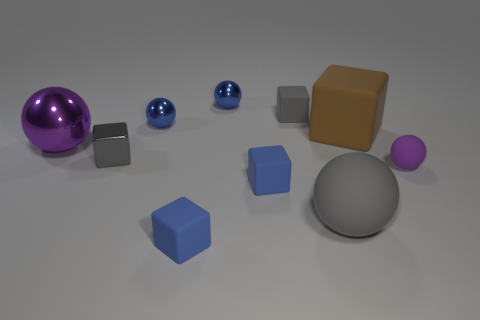Subtract all large rubber spheres. How many spheres are left? 4 Subtract all blue blocks. How many blocks are left? 3 Subtract 2 cubes. How many cubes are left? 3 Subtract all green cubes. How many green balls are left? 0 Subtract all small metallic balls. Subtract all blue balls. How many objects are left? 6 Add 9 large matte blocks. How many large matte blocks are left? 10 Add 1 big brown matte objects. How many big brown matte objects exist? 2 Subtract 1 gray blocks. How many objects are left? 9 Subtract all purple blocks. Subtract all blue cylinders. How many blocks are left? 5 